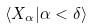Convert formula to latex. <formula><loc_0><loc_0><loc_500><loc_500>\langle X _ { \alpha } | \alpha < \delta \rangle</formula> 